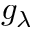Convert formula to latex. <formula><loc_0><loc_0><loc_500><loc_500>g _ { \lambda }</formula> 